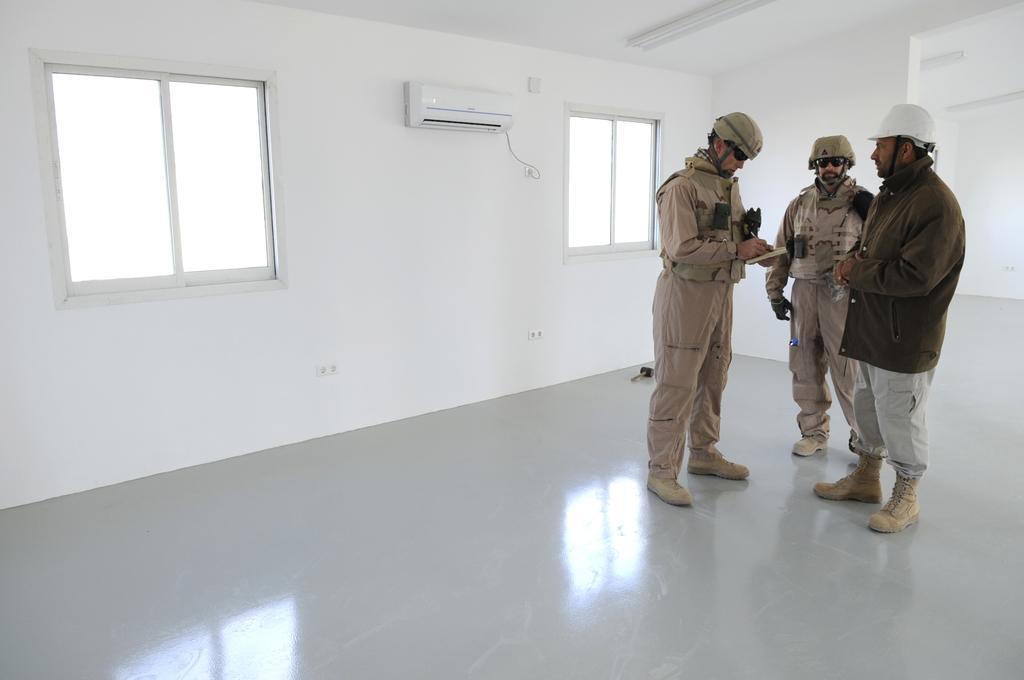How would you summarize this image in a sentence or two? In this picture in the center there are persons standing. In the background there are windows and there is an air conditioner on the wall, there is a wire. 